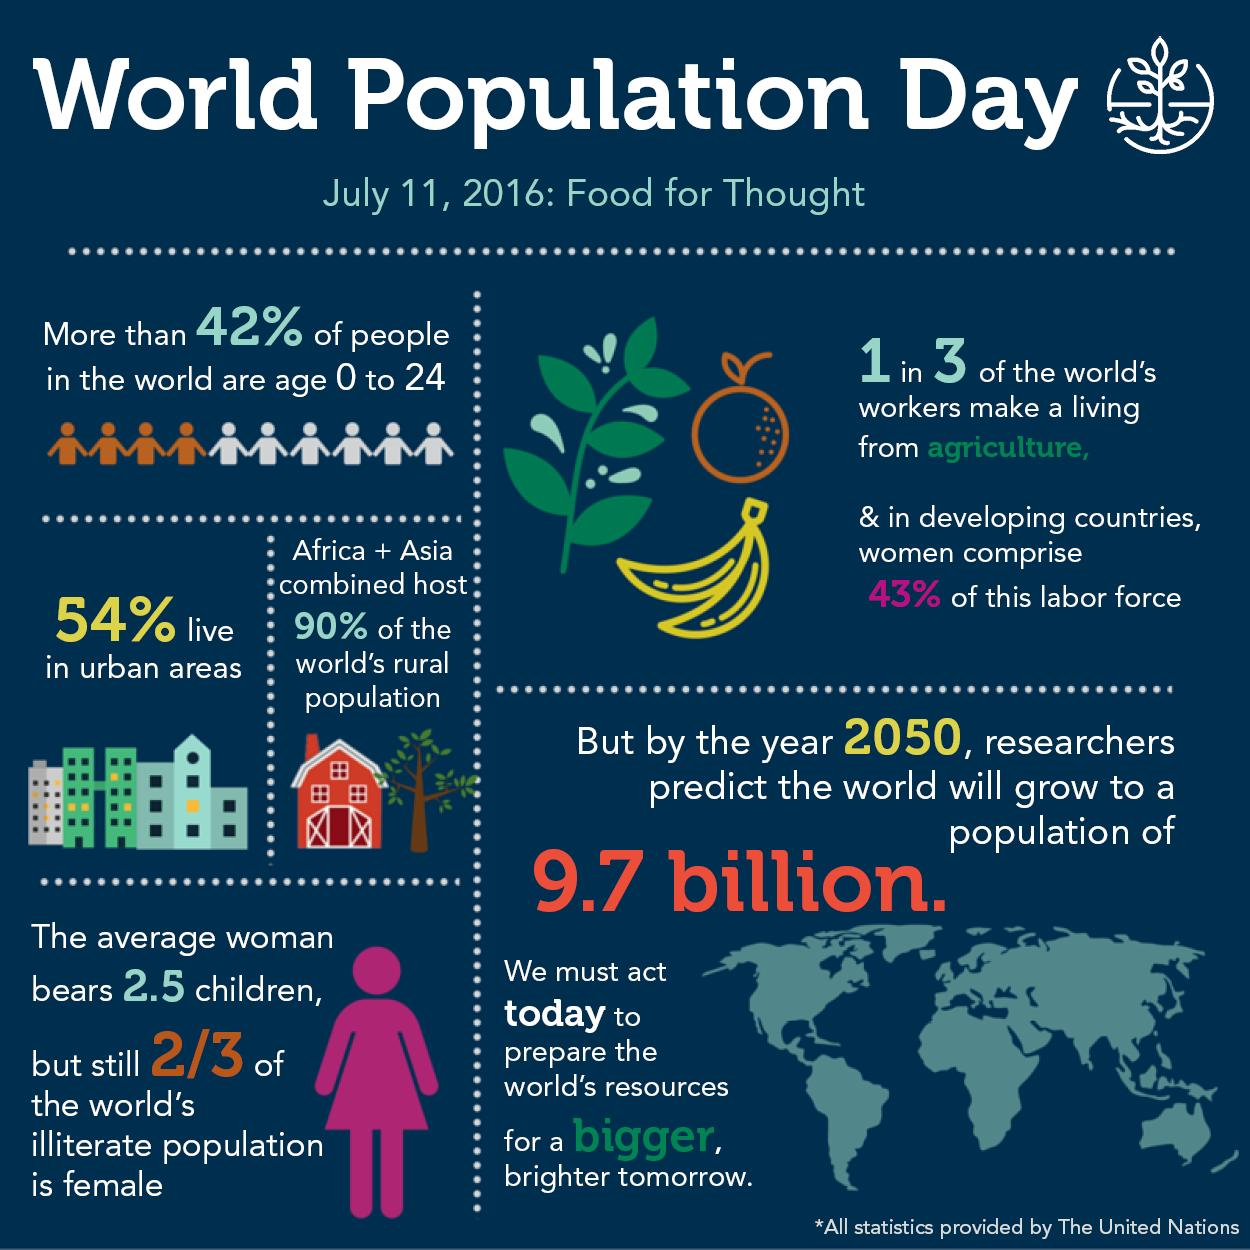Give some essential details in this illustration. The agricultural labor force that is not comprised of women constitutes 57% of the total workforce in the agricultural sector. Approximately one-third of the world's workers rely on agriculture for their livelihoods, according to a recent study. The female population accounts for 66.67% of the world's illiterate population. A significant percentage of the global population is older than 24 years, with 58% falling into this age range. 